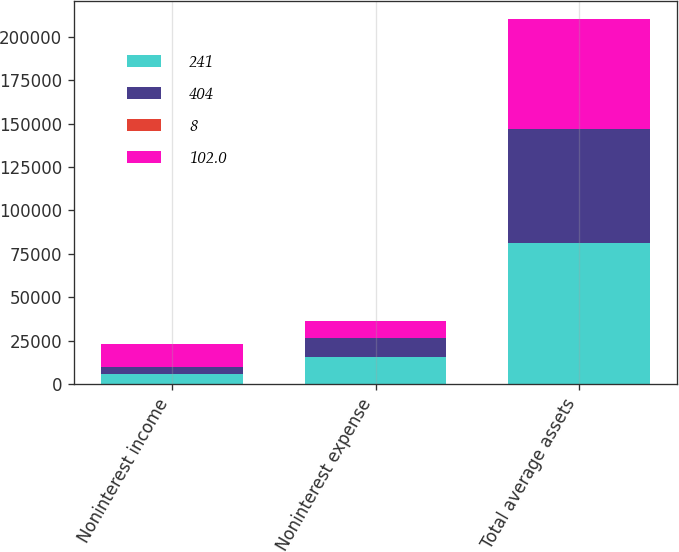Convert chart to OTSL. <chart><loc_0><loc_0><loc_500><loc_500><stacked_bar_chart><ecel><fcel>Noninterest income<fcel>Noninterest expense<fcel>Total average assets<nl><fcel>241<fcel>6078<fcel>15471<fcel>81312<nl><fcel>404<fcel>3961<fcel>11208<fcel>65733<nl><fcel>8<fcel>53.4<fcel>38<fcel>23.7<nl><fcel>102<fcel>13080<fcel>9708<fcel>63047<nl></chart> 